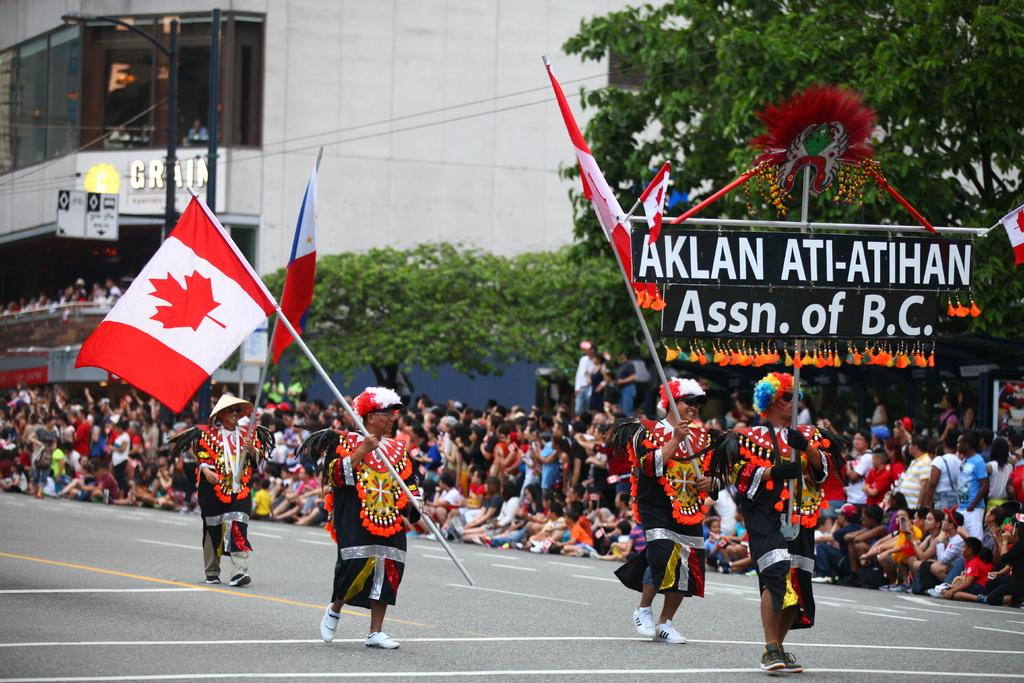What is happening in the image? People are celebrating a festival in the image. Are there any specific flags being held by the people? Yes, some people are holding a Canada flag. What can be seen in the background of the image? The background shows people enjoying the event. Where is the cemetery located in the image? There is no cemetery present in the image; it features a festival celebration. What type of fruit is being sold at the festival in the image? The provided facts do not mention any fruit being sold at the festival, so it cannot be determined from the image. 